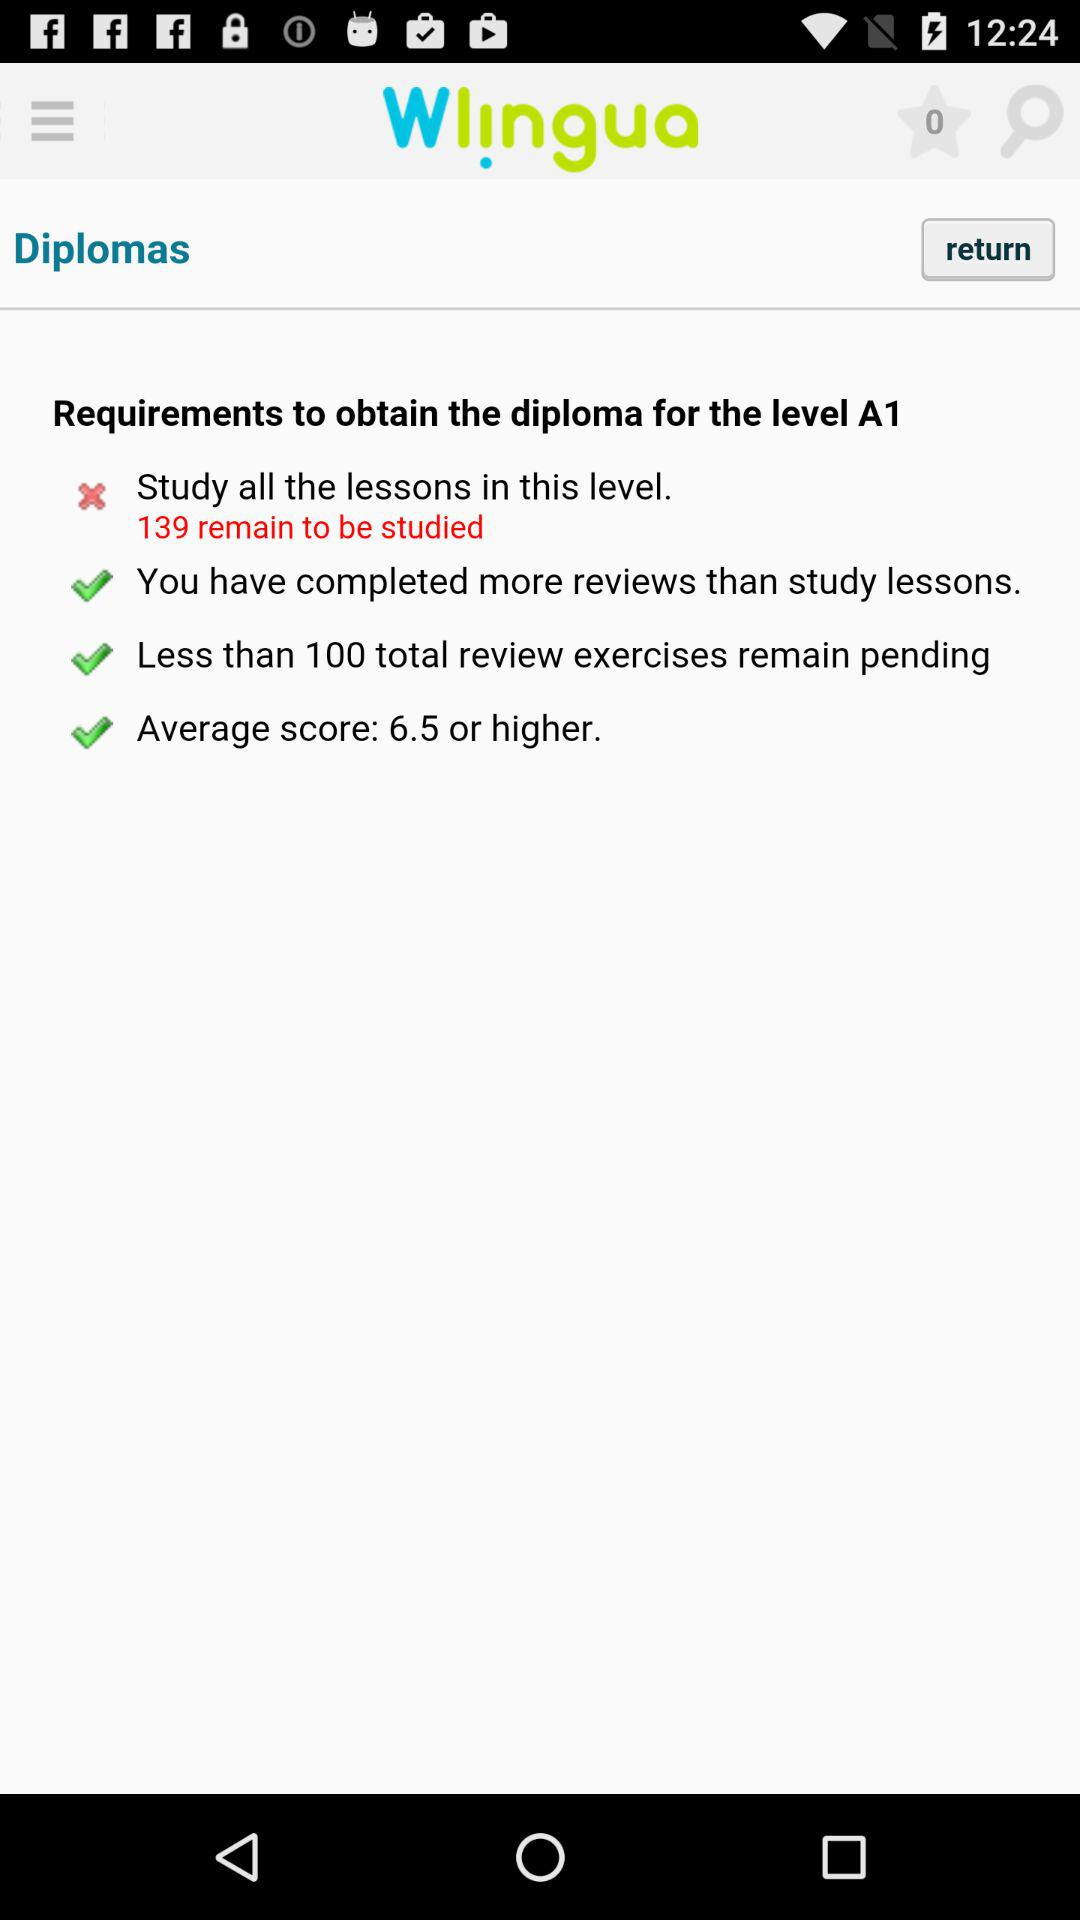What is the count of favorites? The count of favorites is zero. 